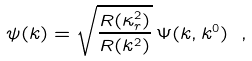Convert formula to latex. <formula><loc_0><loc_0><loc_500><loc_500>\psi ( { k } ) = \sqrt { \frac { R ( \kappa _ { r } ^ { 2 } ) } { R ( { k } ^ { 2 } ) } } \, \Psi ( { k } , k ^ { 0 } ) \ ,</formula> 